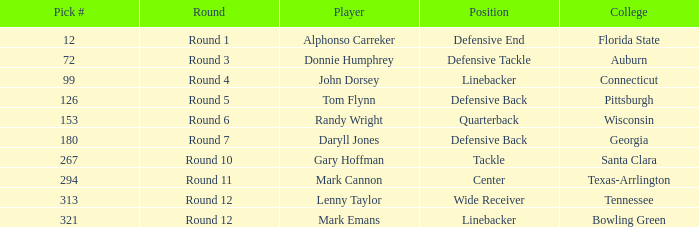During which round was the selection of the 12th pick made? Round 1. 